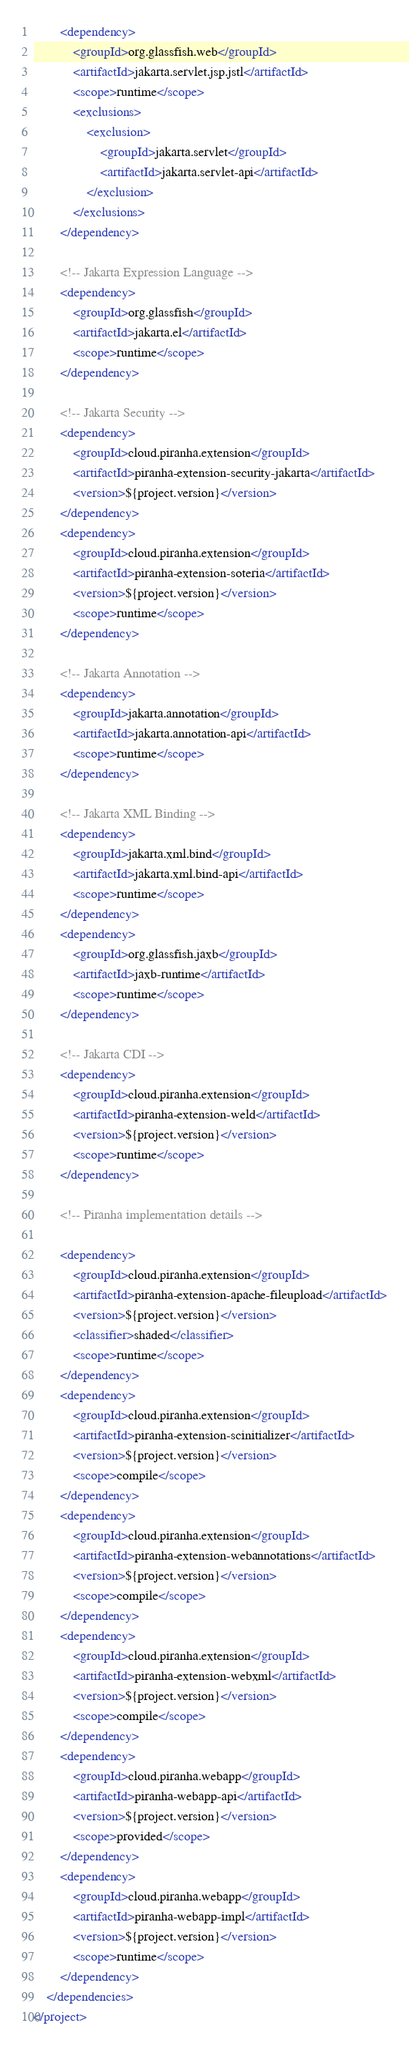<code> <loc_0><loc_0><loc_500><loc_500><_XML_>        <dependency>
            <groupId>org.glassfish.web</groupId>
            <artifactId>jakarta.servlet.jsp.jstl</artifactId>
            <scope>runtime</scope>
            <exclusions>
                <exclusion>
                    <groupId>jakarta.servlet</groupId>
                    <artifactId>jakarta.servlet-api</artifactId>
                </exclusion>
            </exclusions>
        </dependency>
        
        <!-- Jakarta Expression Language -->
        <dependency>
            <groupId>org.glassfish</groupId>
            <artifactId>jakarta.el</artifactId>
            <scope>runtime</scope>
        </dependency>
        
        <!-- Jakarta Security -->
        <dependency>
            <groupId>cloud.piranha.extension</groupId>
            <artifactId>piranha-extension-security-jakarta</artifactId>
            <version>${project.version}</version>
        </dependency>
        <dependency>
            <groupId>cloud.piranha.extension</groupId>
            <artifactId>piranha-extension-soteria</artifactId>
            <version>${project.version}</version>
            <scope>runtime</scope>
        </dependency>
        
        <!-- Jakarta Annotation -->
        <dependency>
            <groupId>jakarta.annotation</groupId>
            <artifactId>jakarta.annotation-api</artifactId>
            <scope>runtime</scope>
        </dependency>
        
        <!-- Jakarta XML Binding -->
        <dependency>
            <groupId>jakarta.xml.bind</groupId>
            <artifactId>jakarta.xml.bind-api</artifactId>
            <scope>runtime</scope>
        </dependency>
        <dependency>
            <groupId>org.glassfish.jaxb</groupId>
            <artifactId>jaxb-runtime</artifactId>
            <scope>runtime</scope>
        </dependency>
        
        <!-- Jakarta CDI -->
        <dependency>
            <groupId>cloud.piranha.extension</groupId>
            <artifactId>piranha-extension-weld</artifactId>
            <version>${project.version}</version>
            <scope>runtime</scope>
        </dependency>        
        
        <!-- Piranha implementation details -->
        
        <dependency>
            <groupId>cloud.piranha.extension</groupId>
            <artifactId>piranha-extension-apache-fileupload</artifactId>
            <version>${project.version}</version>
            <classifier>shaded</classifier>
            <scope>runtime</scope>
        </dependency>
        <dependency>
            <groupId>cloud.piranha.extension</groupId>
            <artifactId>piranha-extension-scinitializer</artifactId>
            <version>${project.version}</version>
            <scope>compile</scope>
        </dependency>
        <dependency>
            <groupId>cloud.piranha.extension</groupId>
            <artifactId>piranha-extension-webannotations</artifactId>
            <version>${project.version}</version>
            <scope>compile</scope>
        </dependency>
        <dependency>
            <groupId>cloud.piranha.extension</groupId>
            <artifactId>piranha-extension-webxml</artifactId>
            <version>${project.version}</version>
            <scope>compile</scope>
        </dependency>
        <dependency>
            <groupId>cloud.piranha.webapp</groupId>
            <artifactId>piranha-webapp-api</artifactId>
            <version>${project.version}</version>
            <scope>provided</scope>
        </dependency>
        <dependency>
            <groupId>cloud.piranha.webapp</groupId>
            <artifactId>piranha-webapp-impl</artifactId>
            <version>${project.version}</version>
            <scope>runtime</scope>
        </dependency>
    </dependencies>
</project>
</code> 